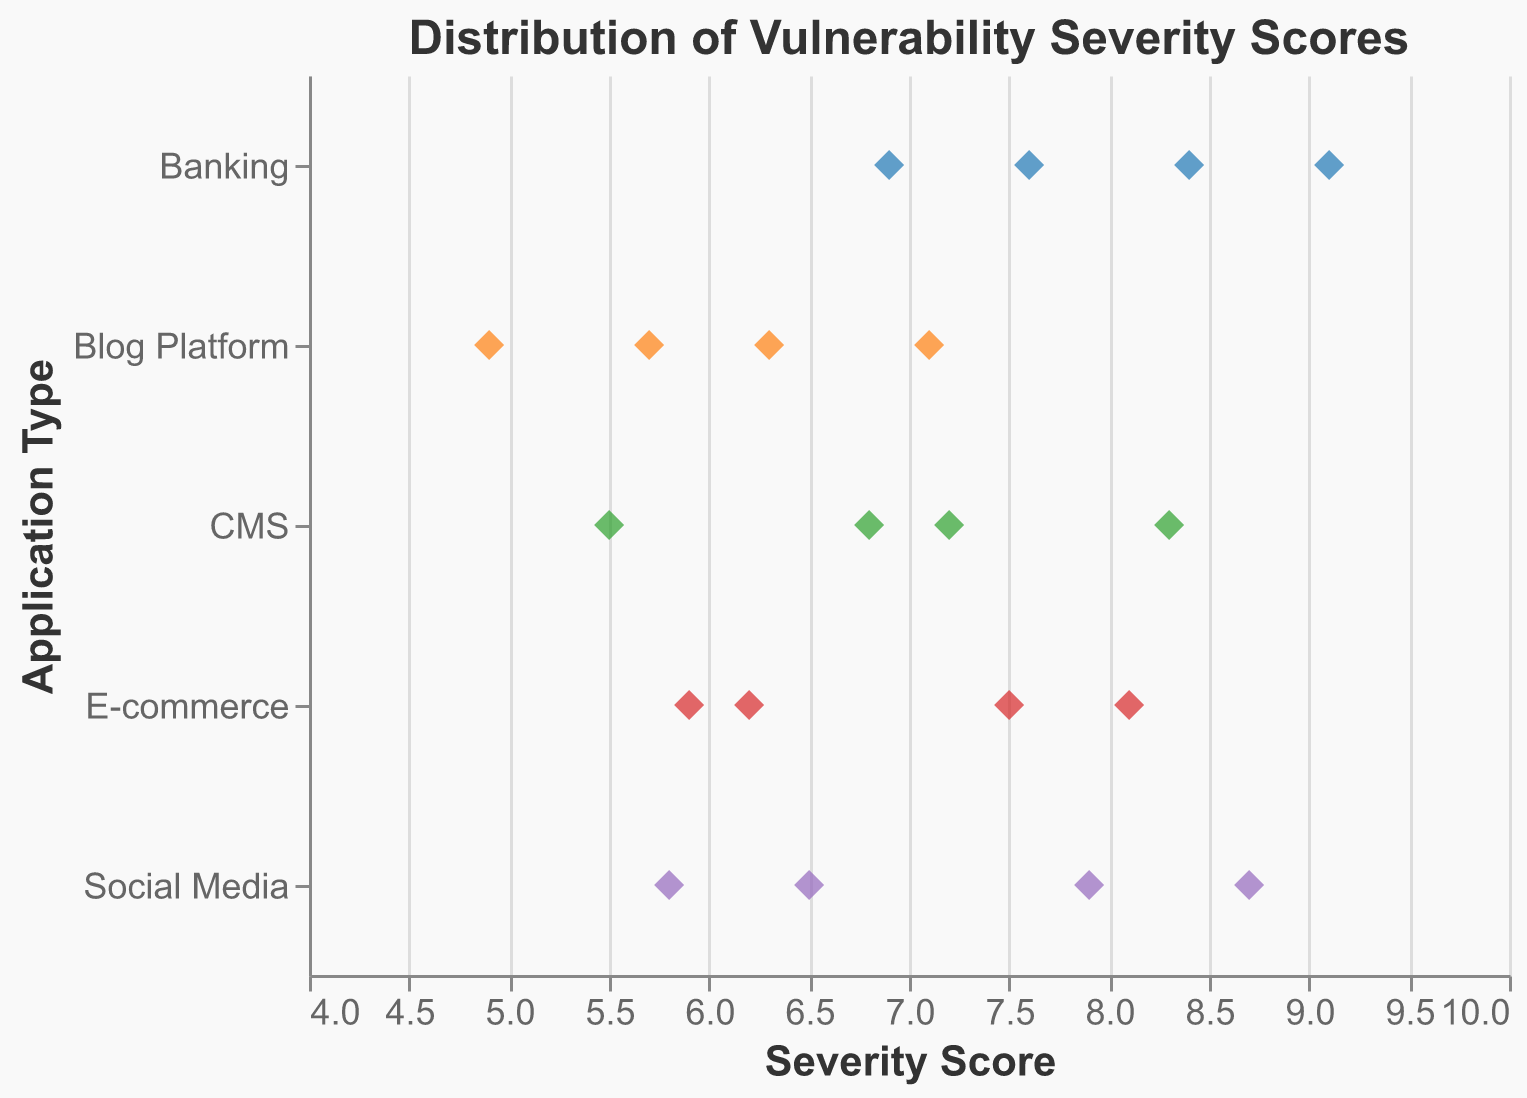What is the title of the plot? The title of a plot is usually located at the top of the figure. In this case, the title reads "Distribution of Vulnerability Severity Scores."
Answer: Distribution of Vulnerability Severity Scores What are the two axes labeled? The x-axis label indicates the measure being plotted against the horizontal dimension, which here is "Severity Score." The y-axis label names the categories being plotted in the vertical dimension, which is "Application Type."
Answer: Severity Score and Application Type How many different types of web applications are displayed in this strip plot? To count the distinct categories shown on the y-axis, identify each unique application type listed: "E-commerce", "CMS", "Social Media", "Banking", and "Blog Platform."
Answer: 5 Which application type has the highest severity score? By identifying the highest value on the x-axis and noting the corresponding application type, we find that the "Banking" type has a score of 9.1.
Answer: Banking Which application type shows the widest range of severity scores? To determine the widest range, we must observe the spread of data points on the x-axis for each application type. "Social Media" ranges from 5.8 to 8.7, which appears to be the widest range.
Answer: Social Media What is the average severity score for the E-commerce application type? Sum the severity scores for the "E-commerce" application type and divide by the number of data points: (7.5 + 6.2 + 8.1 + 5.9) / 4 = 6.925.
Answer: 6.925 Compare the average severity scores of CMS and Banking applications. Which one is higher? Calculate the averages for each group. "CMS": (6.8 + 7.2 + 5.5 + 8.3) / 4 = 6.95. "Banking": (9.1 + 8.4 + 7.6 + 6.9) / 4 = 8.0. The average severity score is higher for Banking applications.
Answer: Banking What is the color assigned to the Social Media application type? Look at the color assigned to the data points plotted for "Social Media." It is identified by a specific color in the legend or directly by observing the points. The color is typically distinguishable, and in the provided code, it is "#ff7f0e" or a similar orange shade.
Answer: Orange What is the severity score of the mildest (lowest severity) vulnerability in Blog Platform applications? Identify the smallest x-axis value for the "Blog Platform" application type. This value is 4.9.
Answer: 4.9 Is there an application type with no severity scores above 8? Observe all the severity scores for each application type. "Blog Platform" has no scores above 8.
Answer: Blog Platform 